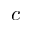<formula> <loc_0><loc_0><loc_500><loc_500>c</formula> 